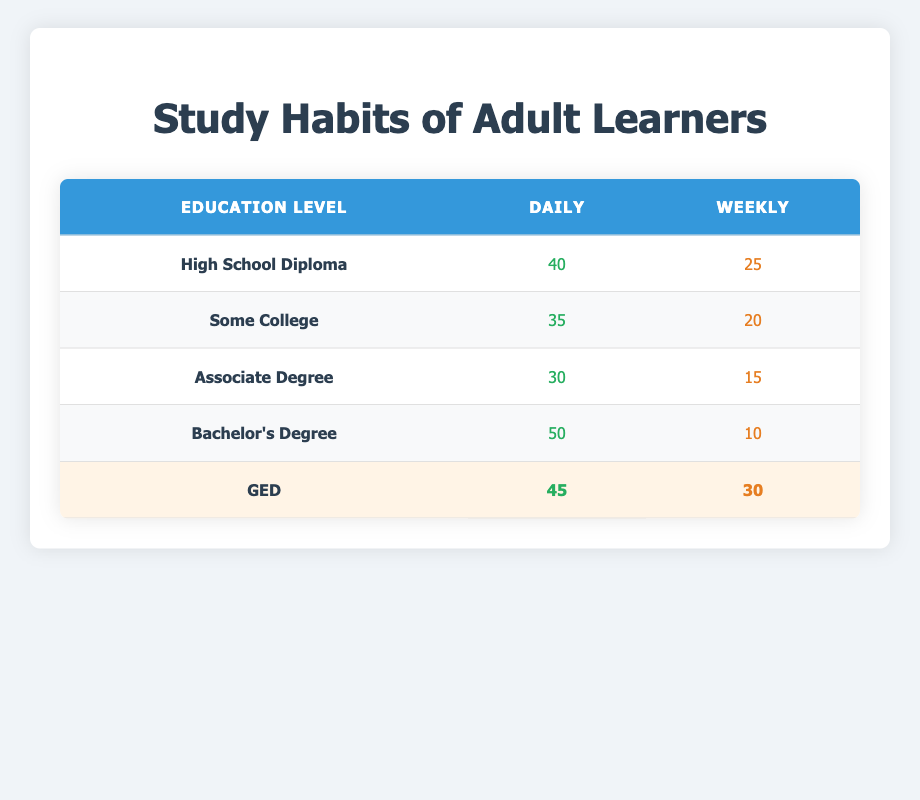What is the count of adult learners with a Bachelor's Degree who study weekly? From the table, I can find the row for Bachelor's Degree under the Weekly column, which indicates a count of 10.
Answer: 10 How many adult learners with an Associate Degree study daily? Looking at the table, I see that for the Associate Degree in the Daily column, the count is 30.
Answer: 30 Which education level has the highest daily study frequency? By examining the Daily column, the highest count is 50 under the Bachelor's Degree, which is greater than all other counts in that column.
Answer: Bachelor's Degree What is the total count of GED holders who study daily and weekly combined? Combining the values in the Daily (45) and Weekly (30) columns for GED holders: 45 + 30 = 75.
Answer: 75 Is there any education level where the count of weekly study habits exceeds that of daily study habits? By checking each row in the Weekly and Daily columns, the only instance where this occurs is for the Bachelor's Degree, where the Daily (50) is greater than Weekly (10). Thus, the answer is no.
Answer: No What percentage of adult learners with a High School Diploma study weekly? The total count of High School Diploma holders studying is 40 (daily) + 25 (weekly) = 65. The weekly study count is 25. To find the percentage, divide 25 by 65 and multiply by 100, which results in approximately 38.46%.
Answer: 38.46% What is the average study frequency for adult learners studying daily across all education levels? To find the average, sum all daily counts: 40 + 35 + 30 + 50 + 45 = 200. There are 5 education levels, so average = 200 / 5 = 40.
Answer: 40 Do GED holders have a higher weekly study count compared to those with an Associate Degree? Comparing the Weekly counts, GED holders have 30 while Associate Degree holders have 15, thus GED holders have a higher count.
Answer: Yes How many more adult learners with a High School Diploma study daily than those with Some College? The count of daily study for High School Diploma holders is 40 and for Some College holders is 35. The difference is 40 - 35 = 5.
Answer: 5 